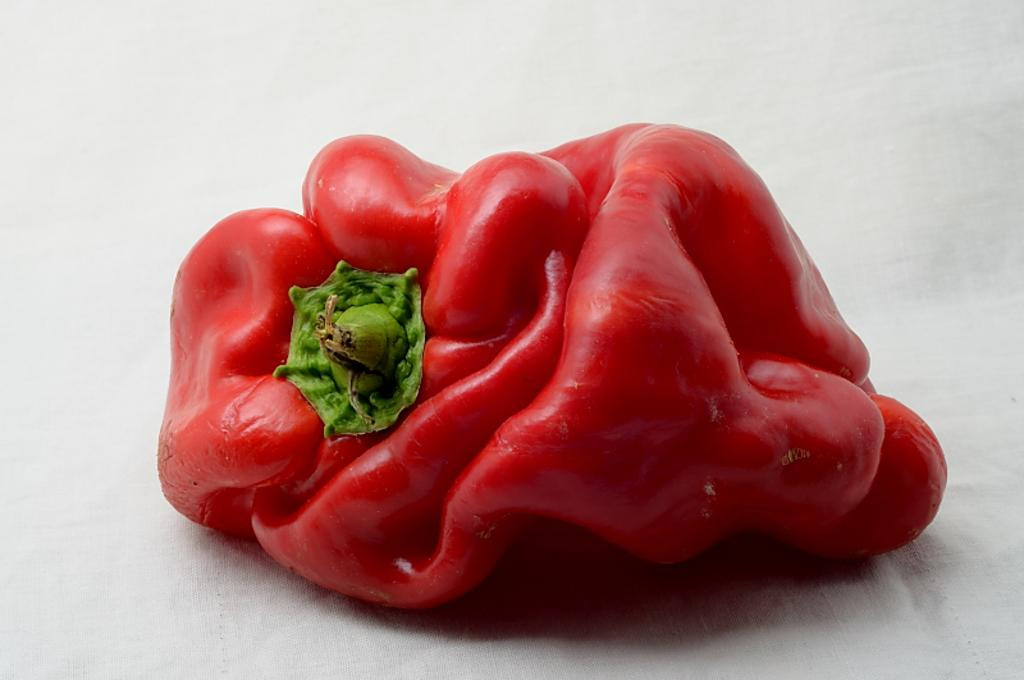What is the main subject of the image? The main subject of the image is a capsicum. Where is the capsicum located in the image? The capsicum is in the middle of the image. What type of seat can be seen in the image? There is no seat present in the image; it features a capsicum in the middle. What is the reason for the capsicum's existence in the image? The reason for the capsicum's existence in the image cannot be determined from the image itself. 